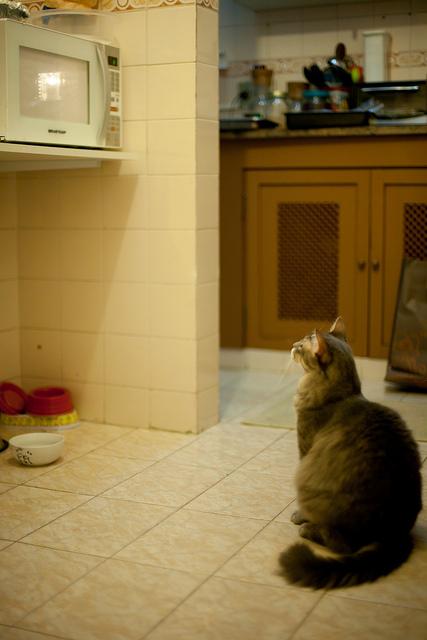Is the microwave on?
Answer briefly. Yes. Can the animal open the door?
Write a very short answer. No. Is the cat on the floor?
Concise answer only. Yes. 